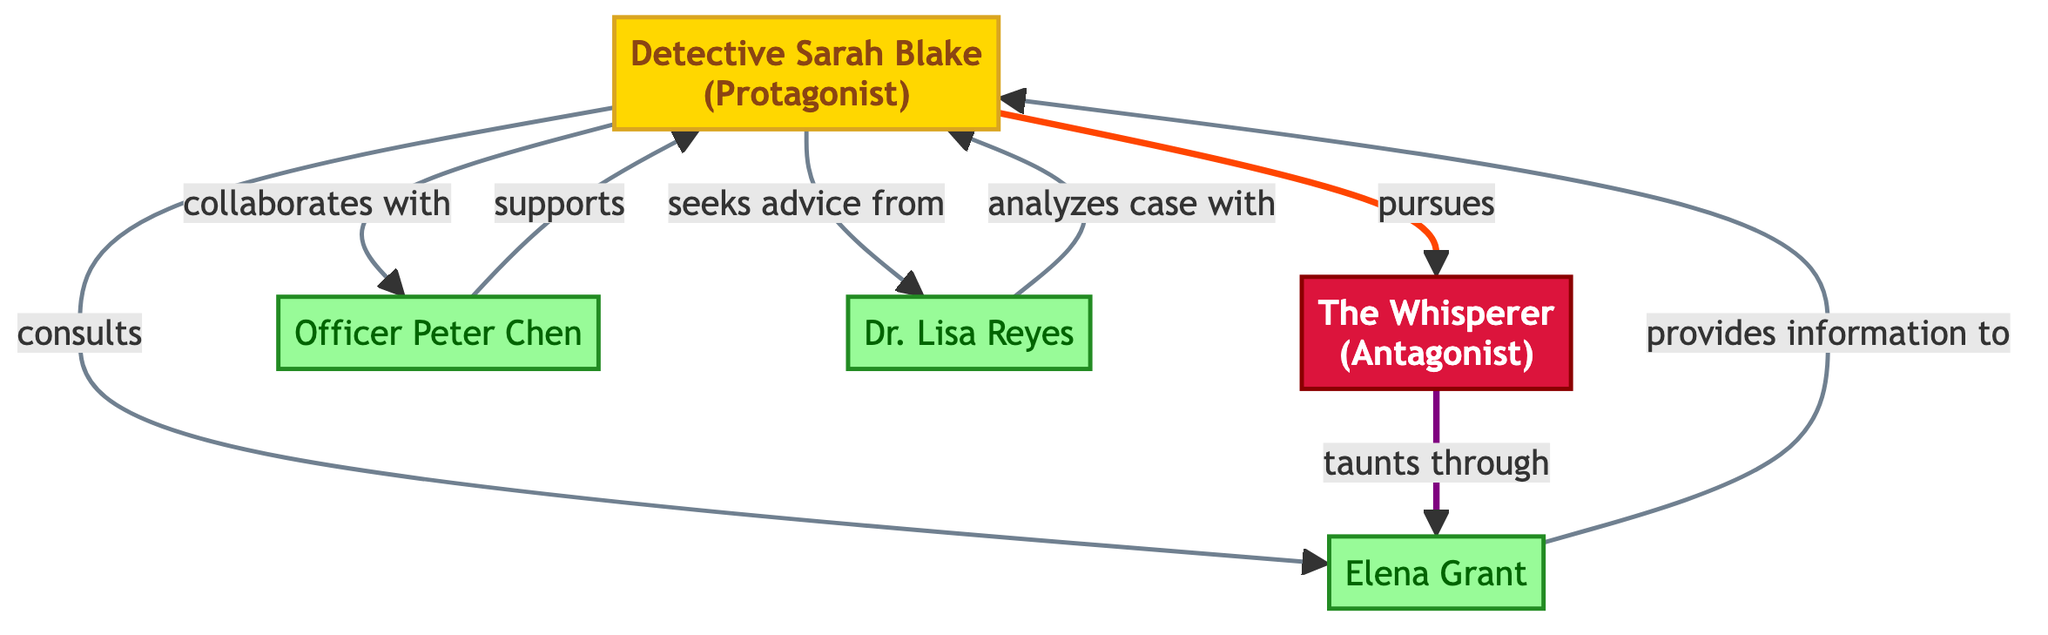What is the main character in the diagram? The main character identified in the diagram is "Detective Sarah Blake," as indicated by the label "Protagonist."
Answer: Detective Sarah Blake Who does the protagonist pursue? The edge in the diagram indicates that the protagonist, Detective Sarah Blake, is pursuing "The Whisperer," the antagonist.
Answer: The Whisperer How many supporting characters are there? The diagram shows three supporting characters: Officer Peter Chen, Elena Grant, and Dr. Lisa Reyes, making a total of three.
Answer: Three What is the relationship between Officer Peter Chen and Detective Sarah Blake? The diagram illustrates a directed edge from Detective Sarah Blake to Officer Peter Chen indicating that she "collaborates with" him, while the reversed direction states that he "supports" her.
Answer: collaborates with How does the antagonist interact with Elena Grant? The diagram specifies that "The Whisperer" taunts Elena Grant through riddles, establishing a direct relationship shown by the edge.
Answer: taunts through What role does Dr. Lisa Reyes have in relation to the protagonist? The diagram shows two relationships between Dr. Lisa Reyes and Detective Sarah Blake: she is consulted by the protagonist and also analyzes the case with her, indicating a supportive role.
Answer: seeks advice from Which character provides information to the protagonist? The directed edge from Elena Grant to Detective Sarah Blake indicates that Elena provides information to the protagonist.
Answer: provides information to Who is the antagonist in the story? The antagonist identified in the diagram is "The Whisperer," as labeled under the "Antagonist" classification.
Answer: The Whisperer Explain the nature of the relationship between the protagonist and supporting character three. The diagram indicates that the protagonist, Detective Sarah Blake, seeks advice from Dr. Lisa Reyes, which highlights a cooperative and advisory relationship between them.
Answer: seeks advice from 